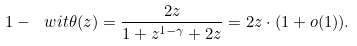<formula> <loc_0><loc_0><loc_500><loc_500>1 - \ w i t \theta ( z ) = \frac { 2 z } { 1 + z ^ { 1 - \gamma } + 2 z } = 2 z \cdot ( 1 + o ( 1 ) ) .</formula> 